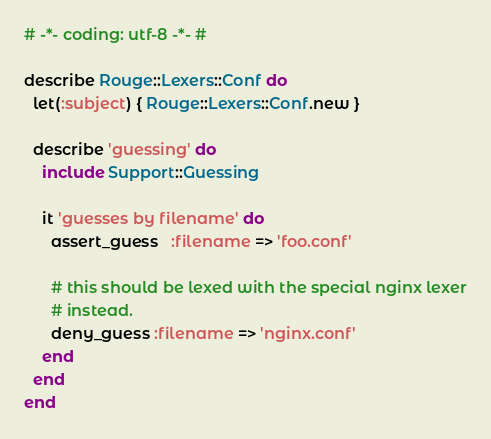<code> <loc_0><loc_0><loc_500><loc_500><_Ruby_># -*- coding: utf-8 -*- #

describe Rouge::Lexers::Conf do
  let(:subject) { Rouge::Lexers::Conf.new }

  describe 'guessing' do
    include Support::Guessing

    it 'guesses by filename' do
      assert_guess   :filename => 'foo.conf'

      # this should be lexed with the special nginx lexer
      # instead.
      deny_guess :filename => 'nginx.conf'
    end
  end
end
</code> 